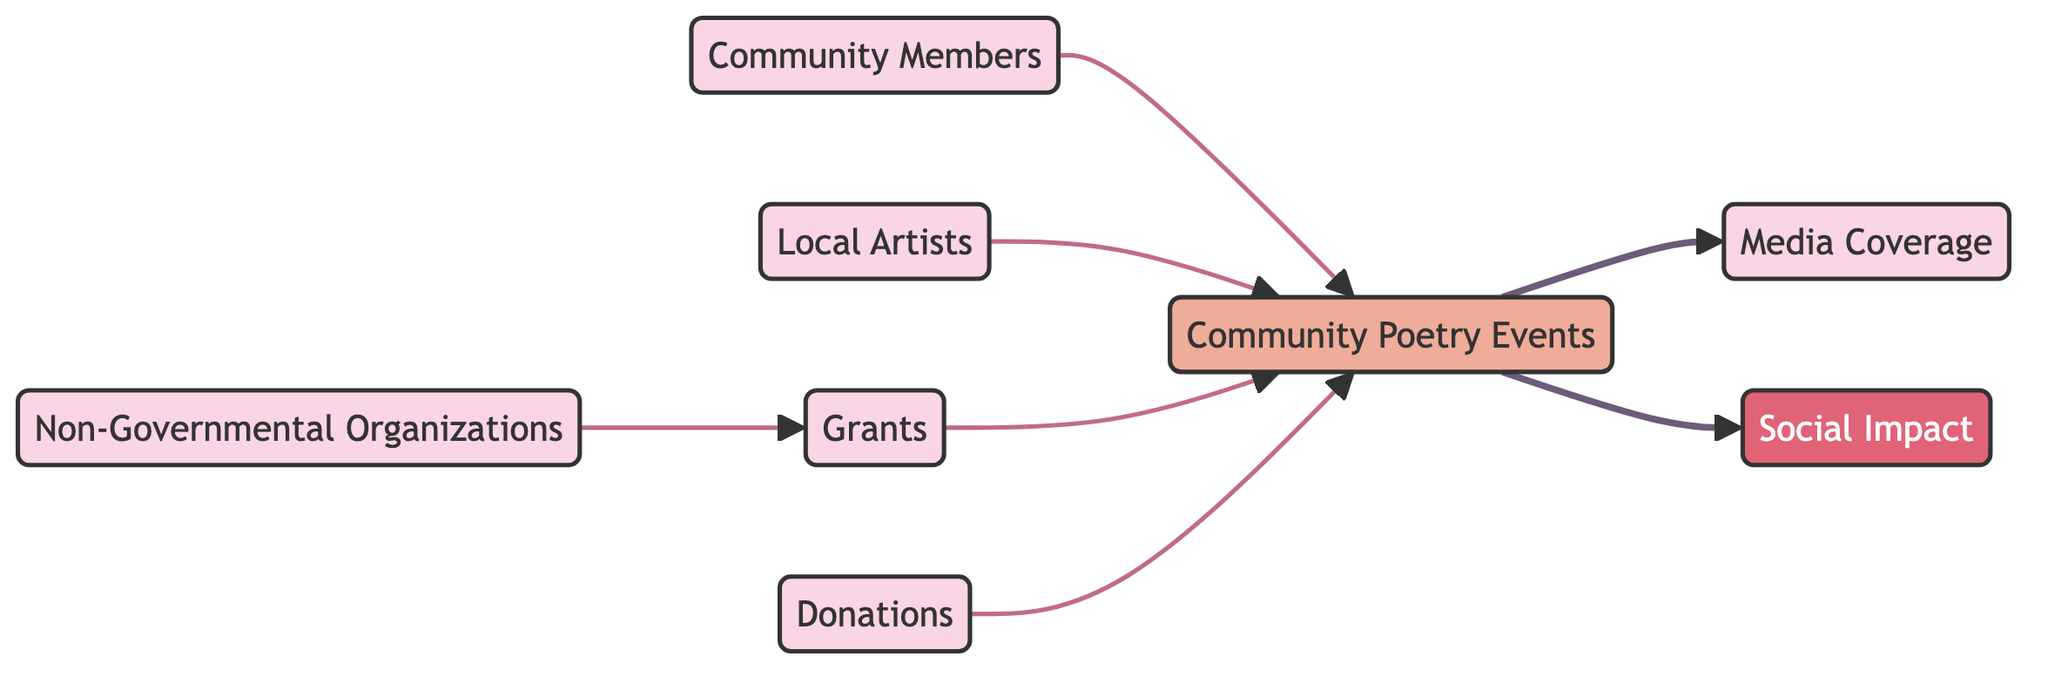What are the nodes in this diagram? The nodes in the diagram represent different entities, which are: Community Members, Local Artists, Non-Governmental Organizations, Grants, Donations, Media Coverage, Social Impact, and Community Poetry Events.
Answer: Community Members, Local Artists, Non-Governmental Organizations, Grants, Donations, Media Coverage, Social Impact, Community Poetry Events How many edges are present in the diagram? To count the edges, we look at the connections between nodes. There are 7 directed edges: Community Members to Poetry Events, Local Artists to Poetry Events, NGOs to Grants, Grants to Poetry Events, Donations to Poetry Events, Poetry Events to Media Coverage, and Poetry Events to Social Impact.
Answer: 7 Which node receives funding from Donations? By observing the edges, Donations have a directed edge leading to Poetry Events, indicating that Poetry Events receive funding from Donations.
Answer: Poetry Events What is the relationship between NGOs and Grants? The directed edge from NGOs to Grants indicates that NGOs provide or facilitate the acquisition of Grants.
Answer: NGOs provide Grants Which entities contribute to Community Poetry Events? Community Members, Local Artists, Grants, and Donations all have directed edges leading into the Poetry Events node, indicating they contribute to it.
Answer: Community Members, Local Artists, Grants, Donations What is the final impact of Community Poetry Events as shown in the diagram? The directed edges from Poetry Events lead to two outcomes: Media Coverage and Social Impact, showing that Poetry Events produce both Media Coverage and Social Impact.
Answer: Media Coverage, Social Impact How many nodes directly influence Social Impact? The directed edge flowing from Poetry Events to Social Impact indicates that only one node directly influences Social Impact, which is Poetry Events itself.
Answer: 1 Which node has the highest involvement in the funding process? Community Poetry Events have direct relationships with Grants, Donations, and input from Community Members and Local Artists, showing it has the highest involvement as the main recipient of funds.
Answer: Community Poetry Events Is there any node that has no outgoing edges? By reviewing the diagram, the node representing Social Impact has no outgoing edges, which means it does not influence any other nodes in the diagram.
Answer: Social Impact 